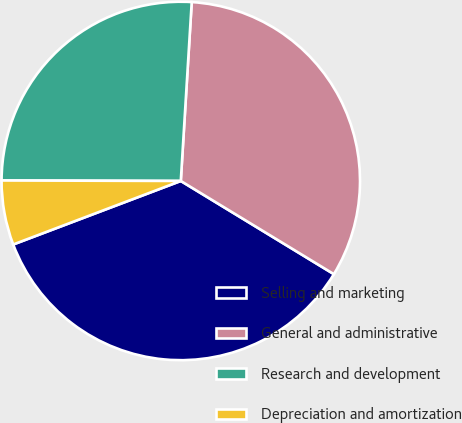Convert chart. <chart><loc_0><loc_0><loc_500><loc_500><pie_chart><fcel>Selling and marketing<fcel>General and administrative<fcel>Research and development<fcel>Depreciation and amortization<nl><fcel>35.53%<fcel>32.73%<fcel>25.93%<fcel>5.81%<nl></chart> 